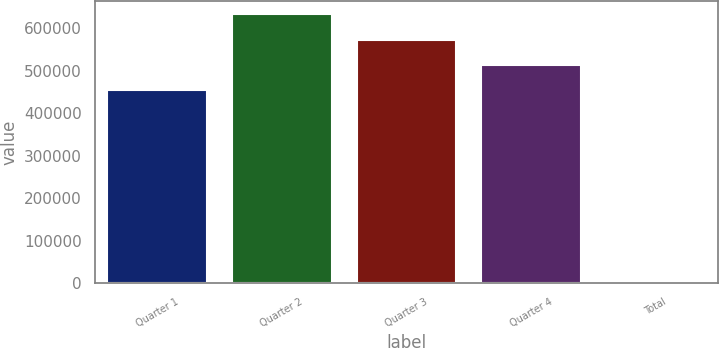Convert chart to OTSL. <chart><loc_0><loc_0><loc_500><loc_500><bar_chart><fcel>Quarter 1<fcel>Quarter 2<fcel>Quarter 3<fcel>Quarter 4<fcel>Total<nl><fcel>454605<fcel>632394<fcel>573131<fcel>513868<fcel>10.16<nl></chart> 